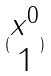<formula> <loc_0><loc_0><loc_500><loc_500>( \begin{matrix} x ^ { 0 } \\ 1 \end{matrix} )</formula> 